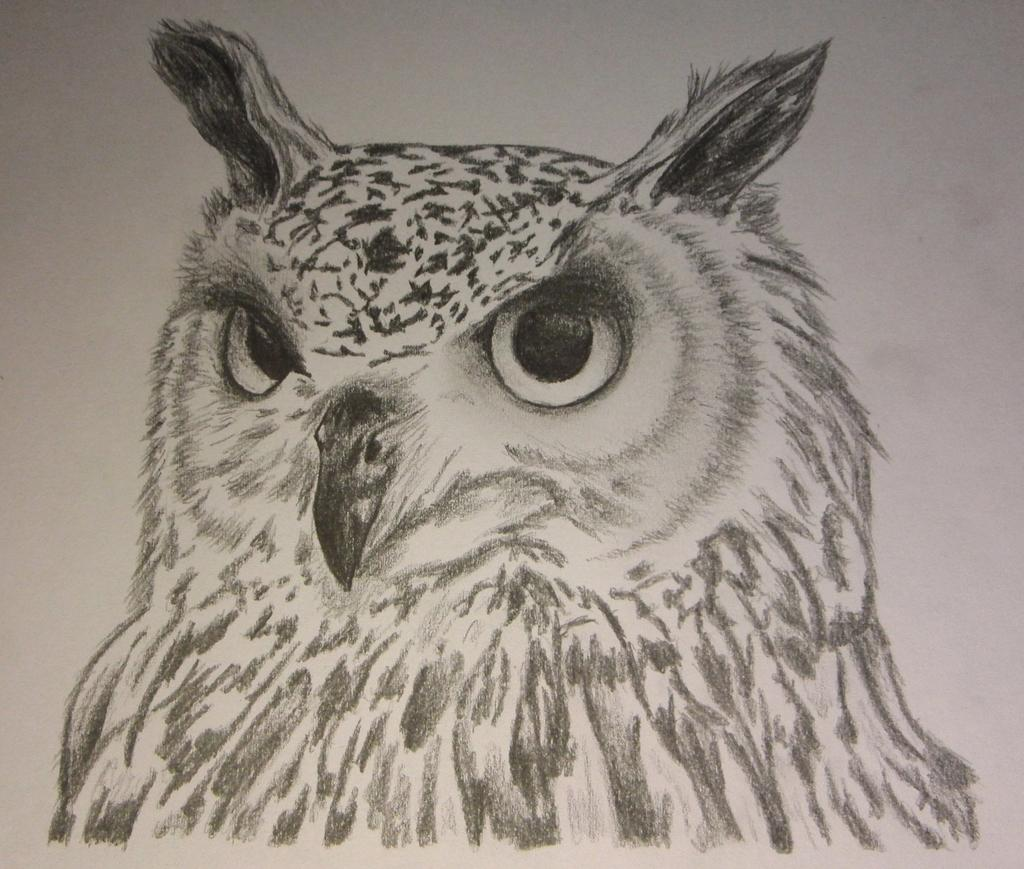What is present on the paper in the image? The paper has an art of an owl on it. Can you describe the art on the paper? The art on the paper is an image of an owl. What type of earth can be seen in the image? There is no earth present in the image; it features a paper with an art of an owl on it. How many pins are visible holding the paper in the image? There are no pins visible in the image; the paper is not being held up by pins. 